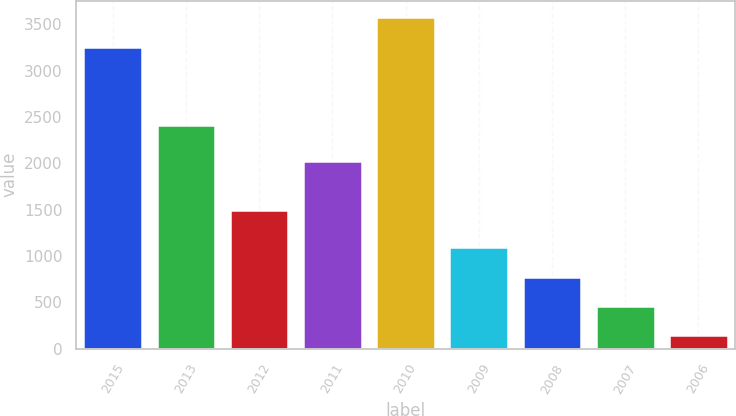Convert chart. <chart><loc_0><loc_0><loc_500><loc_500><bar_chart><fcel>2015<fcel>2013<fcel>2012<fcel>2011<fcel>2010<fcel>2009<fcel>2008<fcel>2007<fcel>2006<nl><fcel>3257<fcel>2416<fcel>1493<fcel>2030<fcel>3574.3<fcel>1095.9<fcel>778.6<fcel>461.3<fcel>144<nl></chart> 